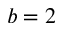<formula> <loc_0><loc_0><loc_500><loc_500>b = 2</formula> 